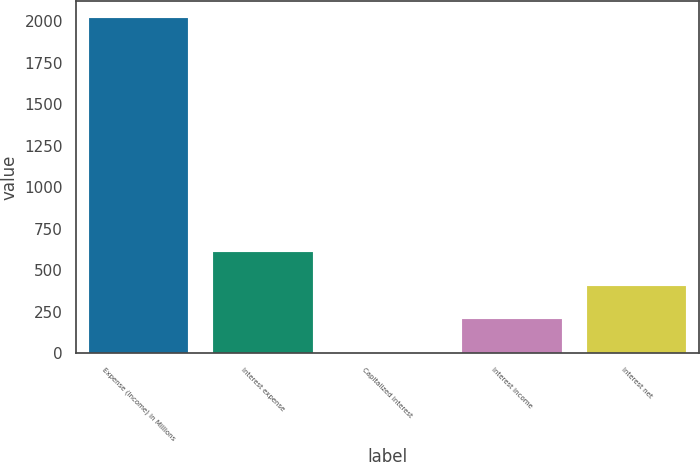Convert chart. <chart><loc_0><loc_0><loc_500><loc_500><bar_chart><fcel>Expense (Income) in Millions<fcel>Interest expense<fcel>Capitalized interest<fcel>Interest income<fcel>Interest net<nl><fcel>2018<fcel>608.27<fcel>4.1<fcel>205.49<fcel>406.88<nl></chart> 